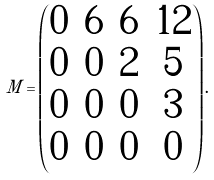Convert formula to latex. <formula><loc_0><loc_0><loc_500><loc_500>M = \begin{pmatrix} 0 & 6 & 6 & 1 2 \\ 0 & 0 & 2 & 5 \\ 0 & 0 & 0 & 3 \\ 0 & 0 & 0 & 0 \end{pmatrix} .</formula> 